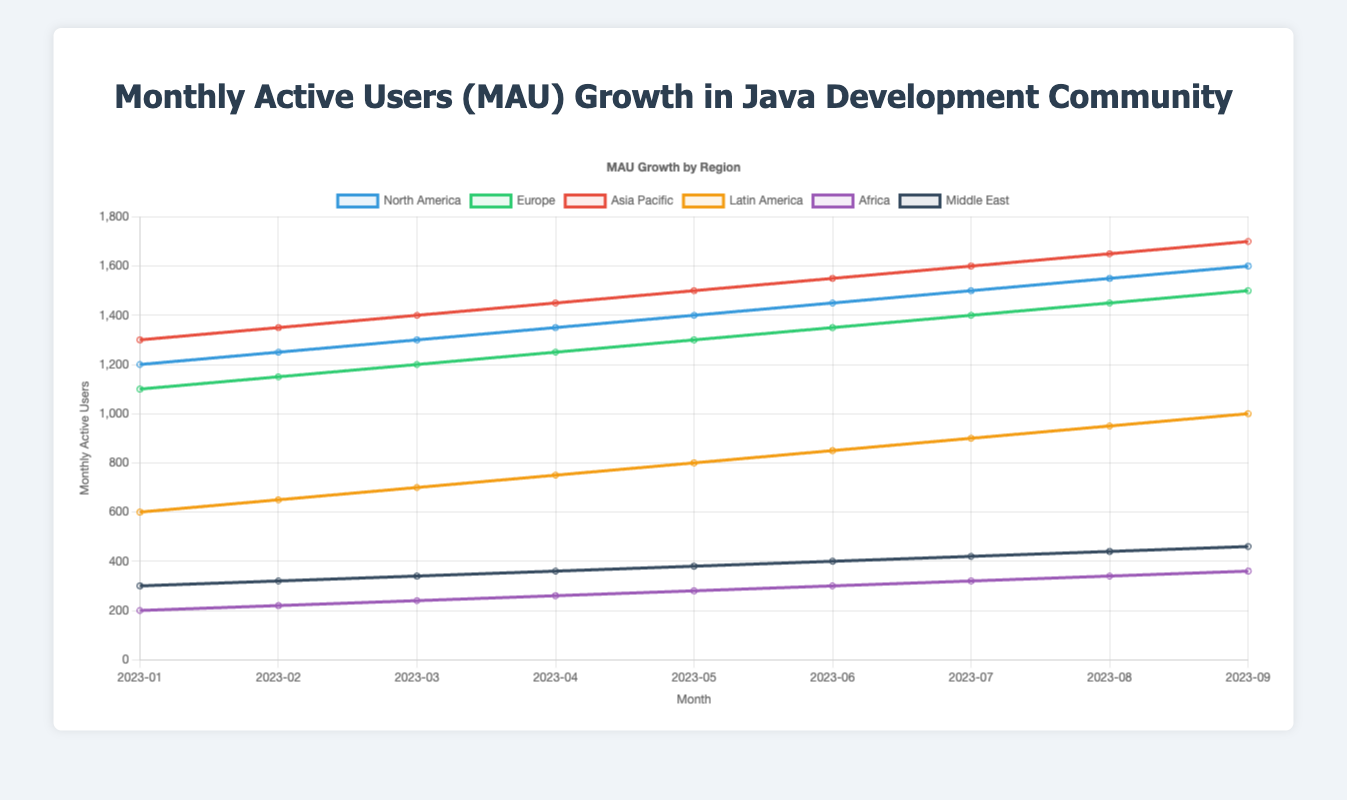What is the total MAU for North America and Europe in March 2023? To find the total MAU for North America and Europe in March 2023, sum the MAU values for both regions: 1300 (North America) + 1200 (Europe) = 2500
Answer: 2500 Which region had the highest MAU in September 2023? In September 2023, the MAU values are: North America (1600), Europe (1500), Asia Pacific (1700), Latin America (1000), Africa (360), and the Middle East (460). The highest value is for Asia Pacific with 1700.
Answer: Asia Pacific Did any region show a steady increase in MAU each month? If so, which one? From January 2023 to September 2023, each region's MAU values can be observed for any steady increase. All regions show a steady increase each month as the MAU values consistently rise without any dips.
Answer: All regions What is the average MAU for Latin America from January to September 2023? To find the average MAU, sum the MAU for each month from January to September and then divide by the number of months (9). The sum is 600 + 650 + 700 + 750 + 800 + 850 + 900 + 950 + 1000 = 7200, so the average is 7200 / 9 = 800
Answer: 800 How much did the MAU increase for Africa from January to May 2023? Subtract the MAU value in January from the MAU value in May: 280 (May) - 200 (January) = 80.
Answer: 80 Compare the MAU of North America and Asia Pacific in July 2023. Which was higher and by how much? In July 2023, the MAU for North America is 1500 and for Asia Pacific is 1600. Asia Pacific's MAU is higher by 1600 - 1500 = 100.
Answer: Asia Pacific, 100 Which two regions had the smallest difference in MAU values in August 2023? The MAU values in August 2023 are: North America (1550), Europe (1450), Asia Pacific (1650), Latin America (950), Africa (340), and the Middle East (440). The smallest difference is between North America (1550) and Europe (1450) with a difference of 1550 - 1450 = 100.
Answer: North America and Europe What is the median value of MAU for Europe from January to September 2023? The MAU values for Europe over 9 months are: 1100, 1150, 1200, 1250, 1300, 1350, 1400, 1450, 1500. To find the median, sort the values and find the middle one: the 5th value in the sorted list is 1300.
Answer: 1300 